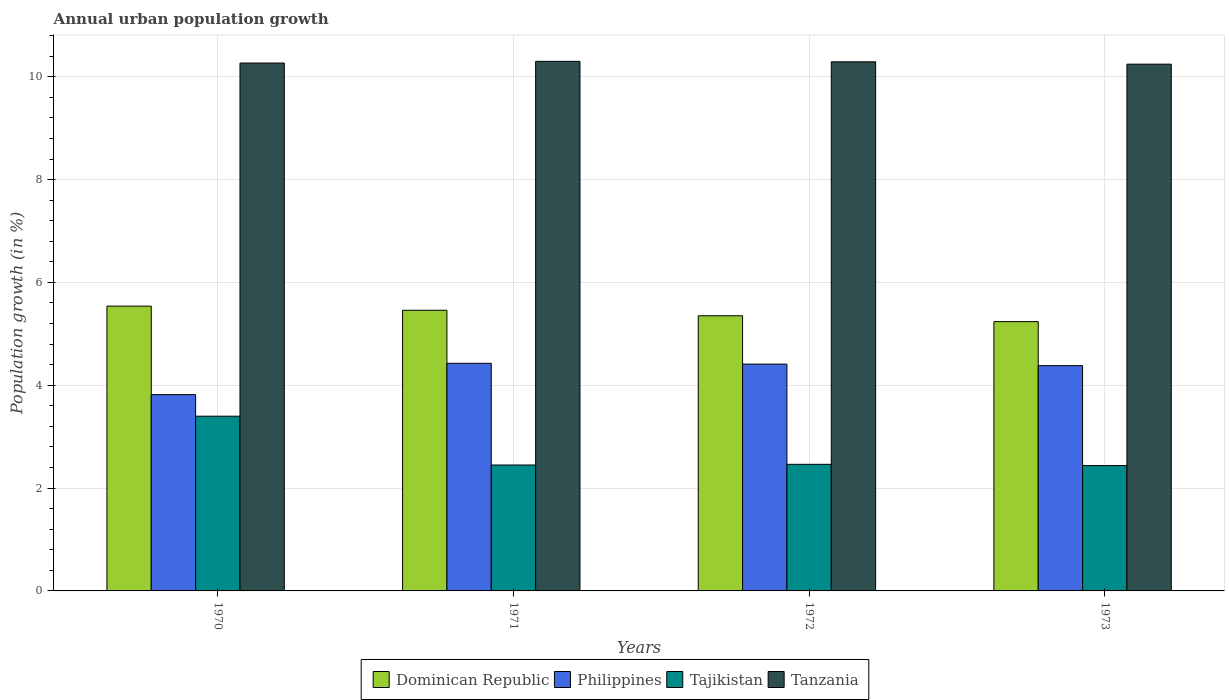How many different coloured bars are there?
Your answer should be very brief. 4. How many bars are there on the 2nd tick from the left?
Provide a succinct answer. 4. How many bars are there on the 2nd tick from the right?
Your response must be concise. 4. What is the label of the 4th group of bars from the left?
Your answer should be very brief. 1973. What is the percentage of urban population growth in Tajikistan in 1970?
Provide a succinct answer. 3.4. Across all years, what is the maximum percentage of urban population growth in Tanzania?
Provide a short and direct response. 10.3. Across all years, what is the minimum percentage of urban population growth in Tajikistan?
Provide a short and direct response. 2.44. In which year was the percentage of urban population growth in Tajikistan maximum?
Give a very brief answer. 1970. What is the total percentage of urban population growth in Tajikistan in the graph?
Ensure brevity in your answer.  10.75. What is the difference between the percentage of urban population growth in Philippines in 1971 and that in 1973?
Provide a short and direct response. 0.05. What is the difference between the percentage of urban population growth in Dominican Republic in 1973 and the percentage of urban population growth in Tanzania in 1971?
Your answer should be compact. -5.06. What is the average percentage of urban population growth in Tajikistan per year?
Offer a very short reply. 2.69. In the year 1971, what is the difference between the percentage of urban population growth in Philippines and percentage of urban population growth in Tanzania?
Provide a succinct answer. -5.87. In how many years, is the percentage of urban population growth in Tanzania greater than 10 %?
Your response must be concise. 4. What is the ratio of the percentage of urban population growth in Philippines in 1970 to that in 1973?
Keep it short and to the point. 0.87. Is the percentage of urban population growth in Tajikistan in 1970 less than that in 1971?
Keep it short and to the point. No. Is the difference between the percentage of urban population growth in Philippines in 1970 and 1971 greater than the difference between the percentage of urban population growth in Tanzania in 1970 and 1971?
Provide a succinct answer. No. What is the difference between the highest and the second highest percentage of urban population growth in Tajikistan?
Ensure brevity in your answer.  0.94. What is the difference between the highest and the lowest percentage of urban population growth in Dominican Republic?
Provide a short and direct response. 0.3. Is it the case that in every year, the sum of the percentage of urban population growth in Philippines and percentage of urban population growth in Tanzania is greater than the sum of percentage of urban population growth in Tajikistan and percentage of urban population growth in Dominican Republic?
Provide a short and direct response. No. What does the 1st bar from the left in 1970 represents?
Make the answer very short. Dominican Republic. Is it the case that in every year, the sum of the percentage of urban population growth in Dominican Republic and percentage of urban population growth in Tanzania is greater than the percentage of urban population growth in Philippines?
Your answer should be very brief. Yes. How many bars are there?
Provide a short and direct response. 16. Are all the bars in the graph horizontal?
Offer a terse response. No. How many years are there in the graph?
Provide a succinct answer. 4. What is the difference between two consecutive major ticks on the Y-axis?
Your answer should be very brief. 2. Are the values on the major ticks of Y-axis written in scientific E-notation?
Your answer should be compact. No. Does the graph contain grids?
Make the answer very short. Yes. How many legend labels are there?
Offer a very short reply. 4. What is the title of the graph?
Your response must be concise. Annual urban population growth. Does "Italy" appear as one of the legend labels in the graph?
Your response must be concise. No. What is the label or title of the Y-axis?
Make the answer very short. Population growth (in %). What is the Population growth (in %) in Dominican Republic in 1970?
Offer a very short reply. 5.54. What is the Population growth (in %) of Philippines in 1970?
Your response must be concise. 3.82. What is the Population growth (in %) in Tajikistan in 1970?
Make the answer very short. 3.4. What is the Population growth (in %) of Tanzania in 1970?
Provide a short and direct response. 10.27. What is the Population growth (in %) in Dominican Republic in 1971?
Provide a short and direct response. 5.46. What is the Population growth (in %) of Philippines in 1971?
Provide a short and direct response. 4.43. What is the Population growth (in %) in Tajikistan in 1971?
Your answer should be compact. 2.45. What is the Population growth (in %) of Tanzania in 1971?
Make the answer very short. 10.3. What is the Population growth (in %) of Dominican Republic in 1972?
Ensure brevity in your answer.  5.35. What is the Population growth (in %) of Philippines in 1972?
Your answer should be compact. 4.41. What is the Population growth (in %) of Tajikistan in 1972?
Ensure brevity in your answer.  2.46. What is the Population growth (in %) in Tanzania in 1972?
Ensure brevity in your answer.  10.29. What is the Population growth (in %) of Dominican Republic in 1973?
Your answer should be very brief. 5.24. What is the Population growth (in %) of Philippines in 1973?
Your answer should be compact. 4.38. What is the Population growth (in %) of Tajikistan in 1973?
Give a very brief answer. 2.44. What is the Population growth (in %) in Tanzania in 1973?
Give a very brief answer. 10.24. Across all years, what is the maximum Population growth (in %) in Dominican Republic?
Offer a very short reply. 5.54. Across all years, what is the maximum Population growth (in %) in Philippines?
Ensure brevity in your answer.  4.43. Across all years, what is the maximum Population growth (in %) of Tajikistan?
Your response must be concise. 3.4. Across all years, what is the maximum Population growth (in %) in Tanzania?
Ensure brevity in your answer.  10.3. Across all years, what is the minimum Population growth (in %) in Dominican Republic?
Your response must be concise. 5.24. Across all years, what is the minimum Population growth (in %) of Philippines?
Offer a very short reply. 3.82. Across all years, what is the minimum Population growth (in %) of Tajikistan?
Provide a succinct answer. 2.44. Across all years, what is the minimum Population growth (in %) of Tanzania?
Your response must be concise. 10.24. What is the total Population growth (in %) in Dominican Republic in the graph?
Your answer should be very brief. 21.59. What is the total Population growth (in %) in Philippines in the graph?
Provide a short and direct response. 17.04. What is the total Population growth (in %) in Tajikistan in the graph?
Offer a terse response. 10.75. What is the total Population growth (in %) of Tanzania in the graph?
Provide a short and direct response. 41.1. What is the difference between the Population growth (in %) of Dominican Republic in 1970 and that in 1971?
Your answer should be compact. 0.08. What is the difference between the Population growth (in %) of Philippines in 1970 and that in 1971?
Provide a succinct answer. -0.61. What is the difference between the Population growth (in %) in Tajikistan in 1970 and that in 1971?
Make the answer very short. 0.95. What is the difference between the Population growth (in %) of Tanzania in 1970 and that in 1971?
Give a very brief answer. -0.03. What is the difference between the Population growth (in %) of Dominican Republic in 1970 and that in 1972?
Ensure brevity in your answer.  0.19. What is the difference between the Population growth (in %) in Philippines in 1970 and that in 1972?
Your answer should be compact. -0.59. What is the difference between the Population growth (in %) in Tajikistan in 1970 and that in 1972?
Offer a terse response. 0.94. What is the difference between the Population growth (in %) of Tanzania in 1970 and that in 1972?
Keep it short and to the point. -0.02. What is the difference between the Population growth (in %) of Dominican Republic in 1970 and that in 1973?
Your answer should be compact. 0.3. What is the difference between the Population growth (in %) of Philippines in 1970 and that in 1973?
Make the answer very short. -0.56. What is the difference between the Population growth (in %) in Tajikistan in 1970 and that in 1973?
Your answer should be very brief. 0.96. What is the difference between the Population growth (in %) in Tanzania in 1970 and that in 1973?
Your answer should be compact. 0.02. What is the difference between the Population growth (in %) of Dominican Republic in 1971 and that in 1972?
Offer a terse response. 0.11. What is the difference between the Population growth (in %) of Philippines in 1971 and that in 1972?
Provide a succinct answer. 0.02. What is the difference between the Population growth (in %) of Tajikistan in 1971 and that in 1972?
Ensure brevity in your answer.  -0.01. What is the difference between the Population growth (in %) of Tanzania in 1971 and that in 1972?
Your answer should be compact. 0.01. What is the difference between the Population growth (in %) in Dominican Republic in 1971 and that in 1973?
Make the answer very short. 0.22. What is the difference between the Population growth (in %) in Philippines in 1971 and that in 1973?
Provide a short and direct response. 0.05. What is the difference between the Population growth (in %) of Tajikistan in 1971 and that in 1973?
Provide a short and direct response. 0.01. What is the difference between the Population growth (in %) in Tanzania in 1971 and that in 1973?
Offer a terse response. 0.05. What is the difference between the Population growth (in %) in Dominican Republic in 1972 and that in 1973?
Make the answer very short. 0.11. What is the difference between the Population growth (in %) of Philippines in 1972 and that in 1973?
Provide a succinct answer. 0.03. What is the difference between the Population growth (in %) of Tajikistan in 1972 and that in 1973?
Offer a terse response. 0.02. What is the difference between the Population growth (in %) in Tanzania in 1972 and that in 1973?
Provide a succinct answer. 0.05. What is the difference between the Population growth (in %) in Dominican Republic in 1970 and the Population growth (in %) in Philippines in 1971?
Make the answer very short. 1.11. What is the difference between the Population growth (in %) of Dominican Republic in 1970 and the Population growth (in %) of Tajikistan in 1971?
Offer a terse response. 3.09. What is the difference between the Population growth (in %) in Dominican Republic in 1970 and the Population growth (in %) in Tanzania in 1971?
Your answer should be compact. -4.76. What is the difference between the Population growth (in %) in Philippines in 1970 and the Population growth (in %) in Tajikistan in 1971?
Provide a short and direct response. 1.37. What is the difference between the Population growth (in %) in Philippines in 1970 and the Population growth (in %) in Tanzania in 1971?
Provide a succinct answer. -6.48. What is the difference between the Population growth (in %) in Tajikistan in 1970 and the Population growth (in %) in Tanzania in 1971?
Ensure brevity in your answer.  -6.9. What is the difference between the Population growth (in %) of Dominican Republic in 1970 and the Population growth (in %) of Philippines in 1972?
Offer a very short reply. 1.13. What is the difference between the Population growth (in %) in Dominican Republic in 1970 and the Population growth (in %) in Tajikistan in 1972?
Ensure brevity in your answer.  3.08. What is the difference between the Population growth (in %) in Dominican Republic in 1970 and the Population growth (in %) in Tanzania in 1972?
Make the answer very short. -4.75. What is the difference between the Population growth (in %) of Philippines in 1970 and the Population growth (in %) of Tajikistan in 1972?
Your answer should be very brief. 1.35. What is the difference between the Population growth (in %) in Philippines in 1970 and the Population growth (in %) in Tanzania in 1972?
Make the answer very short. -6.47. What is the difference between the Population growth (in %) of Tajikistan in 1970 and the Population growth (in %) of Tanzania in 1972?
Provide a short and direct response. -6.89. What is the difference between the Population growth (in %) of Dominican Republic in 1970 and the Population growth (in %) of Philippines in 1973?
Offer a very short reply. 1.16. What is the difference between the Population growth (in %) in Dominican Republic in 1970 and the Population growth (in %) in Tajikistan in 1973?
Ensure brevity in your answer.  3.1. What is the difference between the Population growth (in %) of Dominican Republic in 1970 and the Population growth (in %) of Tanzania in 1973?
Give a very brief answer. -4.71. What is the difference between the Population growth (in %) of Philippines in 1970 and the Population growth (in %) of Tajikistan in 1973?
Give a very brief answer. 1.38. What is the difference between the Population growth (in %) of Philippines in 1970 and the Population growth (in %) of Tanzania in 1973?
Your answer should be very brief. -6.43. What is the difference between the Population growth (in %) in Tajikistan in 1970 and the Population growth (in %) in Tanzania in 1973?
Your answer should be compact. -6.85. What is the difference between the Population growth (in %) of Dominican Republic in 1971 and the Population growth (in %) of Philippines in 1972?
Make the answer very short. 1.05. What is the difference between the Population growth (in %) in Dominican Republic in 1971 and the Population growth (in %) in Tajikistan in 1972?
Make the answer very short. 3. What is the difference between the Population growth (in %) in Dominican Republic in 1971 and the Population growth (in %) in Tanzania in 1972?
Your response must be concise. -4.83. What is the difference between the Population growth (in %) of Philippines in 1971 and the Population growth (in %) of Tajikistan in 1972?
Your answer should be compact. 1.96. What is the difference between the Population growth (in %) in Philippines in 1971 and the Population growth (in %) in Tanzania in 1972?
Your answer should be very brief. -5.86. What is the difference between the Population growth (in %) of Tajikistan in 1971 and the Population growth (in %) of Tanzania in 1972?
Give a very brief answer. -7.84. What is the difference between the Population growth (in %) in Dominican Republic in 1971 and the Population growth (in %) in Philippines in 1973?
Your response must be concise. 1.08. What is the difference between the Population growth (in %) of Dominican Republic in 1971 and the Population growth (in %) of Tajikistan in 1973?
Provide a short and direct response. 3.02. What is the difference between the Population growth (in %) in Dominican Republic in 1971 and the Population growth (in %) in Tanzania in 1973?
Offer a terse response. -4.79. What is the difference between the Population growth (in %) of Philippines in 1971 and the Population growth (in %) of Tajikistan in 1973?
Offer a very short reply. 1.99. What is the difference between the Population growth (in %) in Philippines in 1971 and the Population growth (in %) in Tanzania in 1973?
Make the answer very short. -5.82. What is the difference between the Population growth (in %) of Tajikistan in 1971 and the Population growth (in %) of Tanzania in 1973?
Your answer should be compact. -7.8. What is the difference between the Population growth (in %) of Dominican Republic in 1972 and the Population growth (in %) of Philippines in 1973?
Your answer should be very brief. 0.97. What is the difference between the Population growth (in %) of Dominican Republic in 1972 and the Population growth (in %) of Tajikistan in 1973?
Offer a very short reply. 2.91. What is the difference between the Population growth (in %) of Dominican Republic in 1972 and the Population growth (in %) of Tanzania in 1973?
Keep it short and to the point. -4.89. What is the difference between the Population growth (in %) in Philippines in 1972 and the Population growth (in %) in Tajikistan in 1973?
Offer a very short reply. 1.97. What is the difference between the Population growth (in %) in Philippines in 1972 and the Population growth (in %) in Tanzania in 1973?
Offer a very short reply. -5.83. What is the difference between the Population growth (in %) in Tajikistan in 1972 and the Population growth (in %) in Tanzania in 1973?
Offer a terse response. -7.78. What is the average Population growth (in %) in Dominican Republic per year?
Your answer should be very brief. 5.4. What is the average Population growth (in %) in Philippines per year?
Provide a succinct answer. 4.26. What is the average Population growth (in %) in Tajikistan per year?
Your answer should be very brief. 2.69. What is the average Population growth (in %) in Tanzania per year?
Ensure brevity in your answer.  10.28. In the year 1970, what is the difference between the Population growth (in %) in Dominican Republic and Population growth (in %) in Philippines?
Provide a short and direct response. 1.72. In the year 1970, what is the difference between the Population growth (in %) in Dominican Republic and Population growth (in %) in Tajikistan?
Your answer should be compact. 2.14. In the year 1970, what is the difference between the Population growth (in %) in Dominican Republic and Population growth (in %) in Tanzania?
Keep it short and to the point. -4.73. In the year 1970, what is the difference between the Population growth (in %) in Philippines and Population growth (in %) in Tajikistan?
Give a very brief answer. 0.42. In the year 1970, what is the difference between the Population growth (in %) in Philippines and Population growth (in %) in Tanzania?
Your answer should be very brief. -6.45. In the year 1970, what is the difference between the Population growth (in %) of Tajikistan and Population growth (in %) of Tanzania?
Give a very brief answer. -6.87. In the year 1971, what is the difference between the Population growth (in %) in Dominican Republic and Population growth (in %) in Philippines?
Offer a very short reply. 1.03. In the year 1971, what is the difference between the Population growth (in %) of Dominican Republic and Population growth (in %) of Tajikistan?
Provide a short and direct response. 3.01. In the year 1971, what is the difference between the Population growth (in %) of Dominican Republic and Population growth (in %) of Tanzania?
Your answer should be compact. -4.84. In the year 1971, what is the difference between the Population growth (in %) in Philippines and Population growth (in %) in Tajikistan?
Your response must be concise. 1.98. In the year 1971, what is the difference between the Population growth (in %) in Philippines and Population growth (in %) in Tanzania?
Provide a short and direct response. -5.87. In the year 1971, what is the difference between the Population growth (in %) in Tajikistan and Population growth (in %) in Tanzania?
Keep it short and to the point. -7.85. In the year 1972, what is the difference between the Population growth (in %) in Dominican Republic and Population growth (in %) in Philippines?
Provide a succinct answer. 0.94. In the year 1972, what is the difference between the Population growth (in %) of Dominican Republic and Population growth (in %) of Tajikistan?
Offer a very short reply. 2.89. In the year 1972, what is the difference between the Population growth (in %) of Dominican Republic and Population growth (in %) of Tanzania?
Your answer should be compact. -4.94. In the year 1972, what is the difference between the Population growth (in %) of Philippines and Population growth (in %) of Tajikistan?
Make the answer very short. 1.95. In the year 1972, what is the difference between the Population growth (in %) of Philippines and Population growth (in %) of Tanzania?
Give a very brief answer. -5.88. In the year 1972, what is the difference between the Population growth (in %) in Tajikistan and Population growth (in %) in Tanzania?
Your answer should be very brief. -7.83. In the year 1973, what is the difference between the Population growth (in %) in Dominican Republic and Population growth (in %) in Philippines?
Make the answer very short. 0.86. In the year 1973, what is the difference between the Population growth (in %) of Dominican Republic and Population growth (in %) of Tajikistan?
Give a very brief answer. 2.8. In the year 1973, what is the difference between the Population growth (in %) of Dominican Republic and Population growth (in %) of Tanzania?
Offer a terse response. -5.01. In the year 1973, what is the difference between the Population growth (in %) of Philippines and Population growth (in %) of Tajikistan?
Your response must be concise. 1.94. In the year 1973, what is the difference between the Population growth (in %) in Philippines and Population growth (in %) in Tanzania?
Keep it short and to the point. -5.86. In the year 1973, what is the difference between the Population growth (in %) in Tajikistan and Population growth (in %) in Tanzania?
Offer a very short reply. -7.81. What is the ratio of the Population growth (in %) of Dominican Republic in 1970 to that in 1971?
Offer a terse response. 1.01. What is the ratio of the Population growth (in %) of Philippines in 1970 to that in 1971?
Offer a terse response. 0.86. What is the ratio of the Population growth (in %) in Tajikistan in 1970 to that in 1971?
Provide a short and direct response. 1.39. What is the ratio of the Population growth (in %) of Dominican Republic in 1970 to that in 1972?
Keep it short and to the point. 1.03. What is the ratio of the Population growth (in %) of Philippines in 1970 to that in 1972?
Provide a succinct answer. 0.87. What is the ratio of the Population growth (in %) in Tajikistan in 1970 to that in 1972?
Ensure brevity in your answer.  1.38. What is the ratio of the Population growth (in %) of Dominican Republic in 1970 to that in 1973?
Your answer should be compact. 1.06. What is the ratio of the Population growth (in %) of Philippines in 1970 to that in 1973?
Provide a succinct answer. 0.87. What is the ratio of the Population growth (in %) of Tajikistan in 1970 to that in 1973?
Provide a succinct answer. 1.39. What is the ratio of the Population growth (in %) of Tanzania in 1970 to that in 1973?
Provide a short and direct response. 1. What is the ratio of the Population growth (in %) of Dominican Republic in 1971 to that in 1972?
Offer a terse response. 1.02. What is the ratio of the Population growth (in %) of Dominican Republic in 1971 to that in 1973?
Give a very brief answer. 1.04. What is the ratio of the Population growth (in %) of Philippines in 1971 to that in 1973?
Keep it short and to the point. 1.01. What is the ratio of the Population growth (in %) of Tajikistan in 1971 to that in 1973?
Offer a terse response. 1. What is the ratio of the Population growth (in %) in Tanzania in 1971 to that in 1973?
Give a very brief answer. 1.01. What is the ratio of the Population growth (in %) in Dominican Republic in 1972 to that in 1973?
Give a very brief answer. 1.02. What is the ratio of the Population growth (in %) of Tanzania in 1972 to that in 1973?
Your response must be concise. 1. What is the difference between the highest and the second highest Population growth (in %) in Dominican Republic?
Provide a succinct answer. 0.08. What is the difference between the highest and the second highest Population growth (in %) in Philippines?
Your answer should be compact. 0.02. What is the difference between the highest and the second highest Population growth (in %) in Tajikistan?
Give a very brief answer. 0.94. What is the difference between the highest and the second highest Population growth (in %) of Tanzania?
Provide a short and direct response. 0.01. What is the difference between the highest and the lowest Population growth (in %) of Dominican Republic?
Keep it short and to the point. 0.3. What is the difference between the highest and the lowest Population growth (in %) in Philippines?
Ensure brevity in your answer.  0.61. What is the difference between the highest and the lowest Population growth (in %) in Tajikistan?
Offer a very short reply. 0.96. What is the difference between the highest and the lowest Population growth (in %) of Tanzania?
Ensure brevity in your answer.  0.05. 